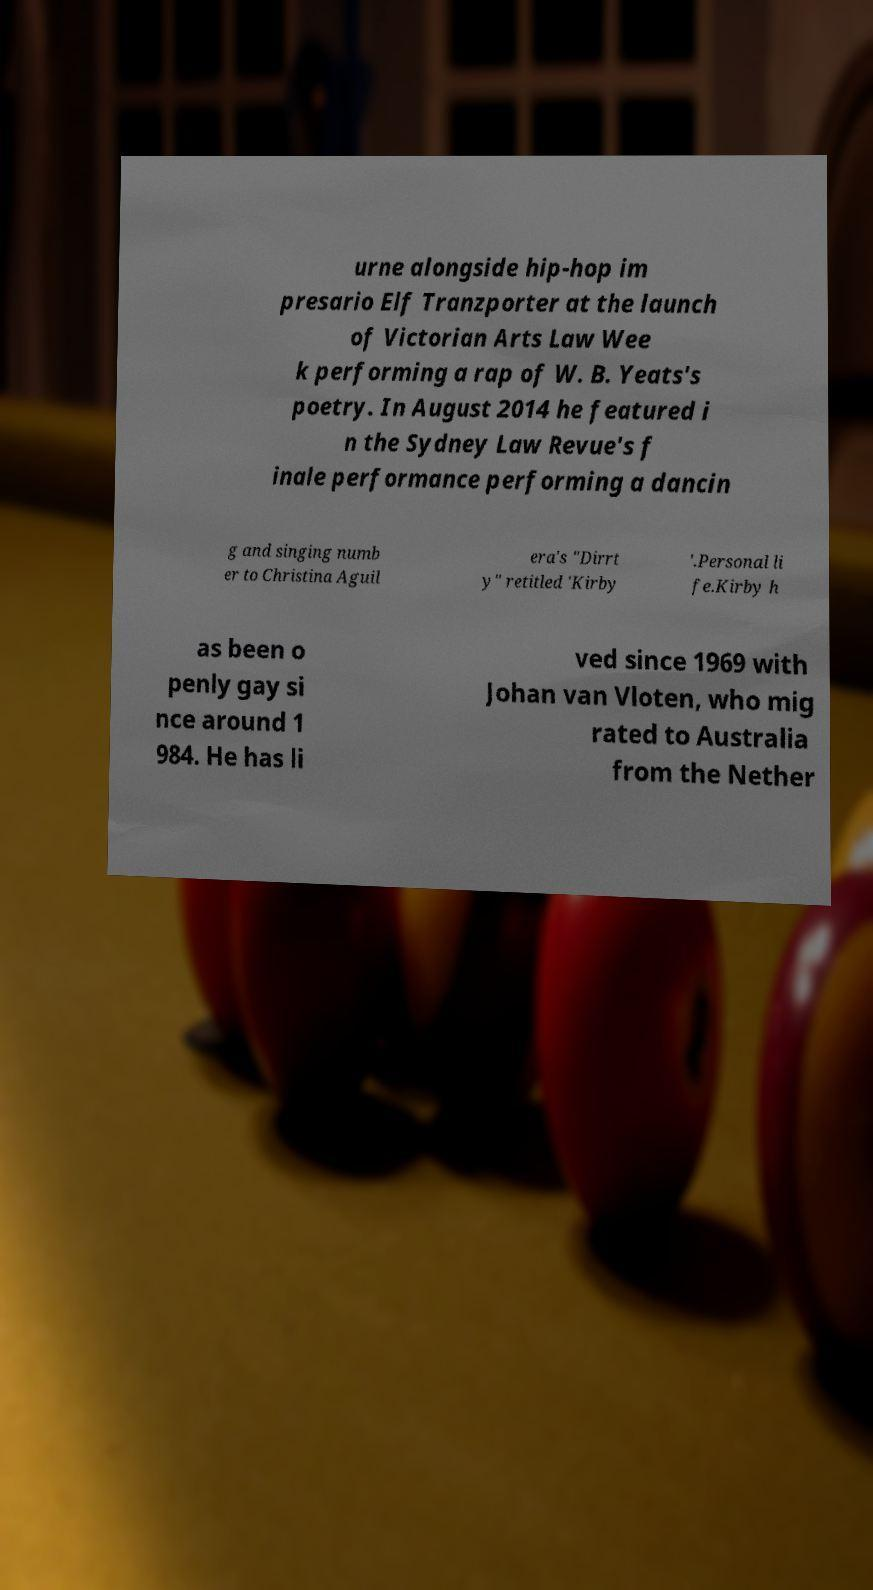Could you assist in decoding the text presented in this image and type it out clearly? urne alongside hip-hop im presario Elf Tranzporter at the launch of Victorian Arts Law Wee k performing a rap of W. B. Yeats's poetry. In August 2014 he featured i n the Sydney Law Revue's f inale performance performing a dancin g and singing numb er to Christina Aguil era's "Dirrt y" retitled 'Kirby '.Personal li fe.Kirby h as been o penly gay si nce around 1 984. He has li ved since 1969 with Johan van Vloten, who mig rated to Australia from the Nether 